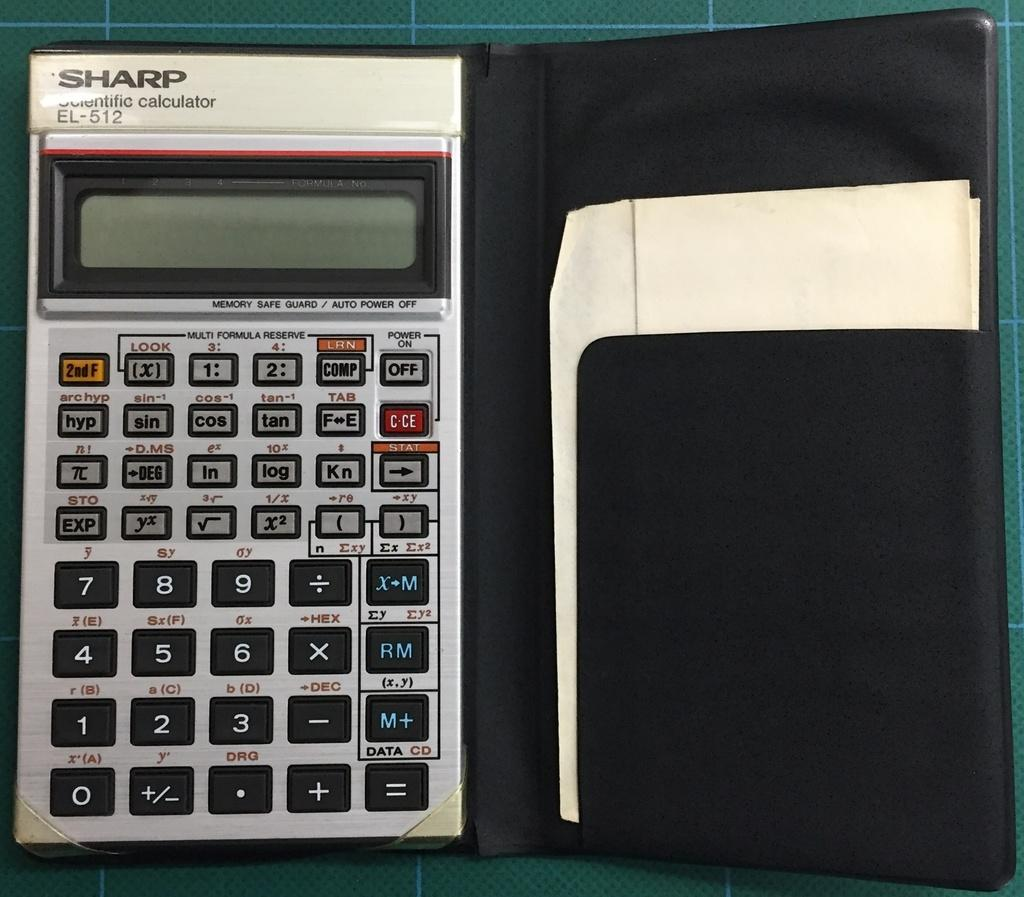<image>
Give a short and clear explanation of the subsequent image. A Sharp scientific calculator is in a black case with a piece of paper in its side pocket. 